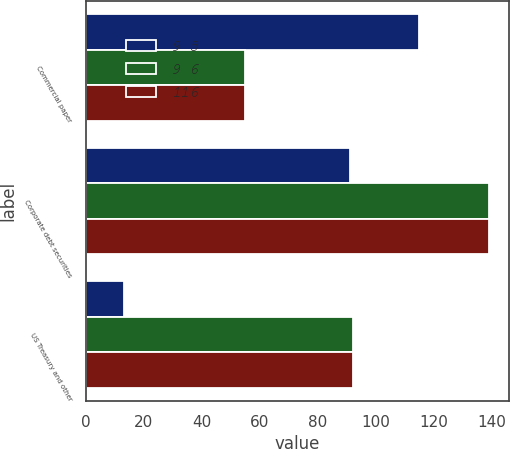<chart> <loc_0><loc_0><loc_500><loc_500><stacked_bar_chart><ecel><fcel>Commercial paper<fcel>Corporate debt securities<fcel>US Treasury and other<nl><fcel>9 5<fcel>115<fcel>91<fcel>13<nl><fcel>9 6<fcel>55<fcel>139<fcel>92<nl><fcel>116<fcel>55<fcel>139<fcel>92<nl></chart> 